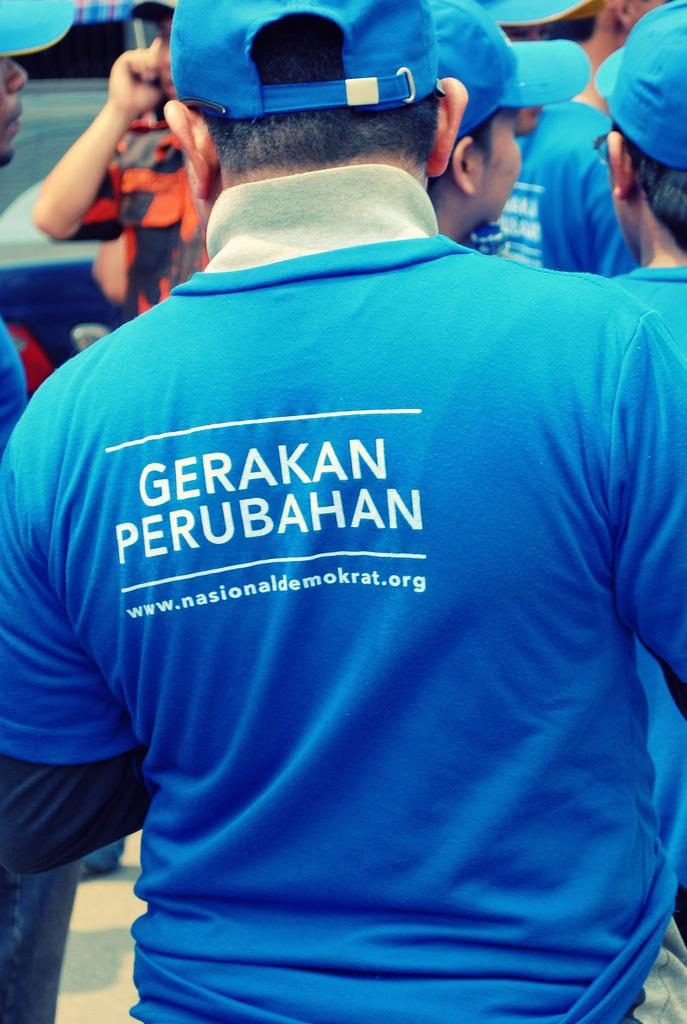<image>
Give a short and clear explanation of the subsequent image. A stocky man wearing a blue shirt has the words Gerakan Perubahan on his back. 